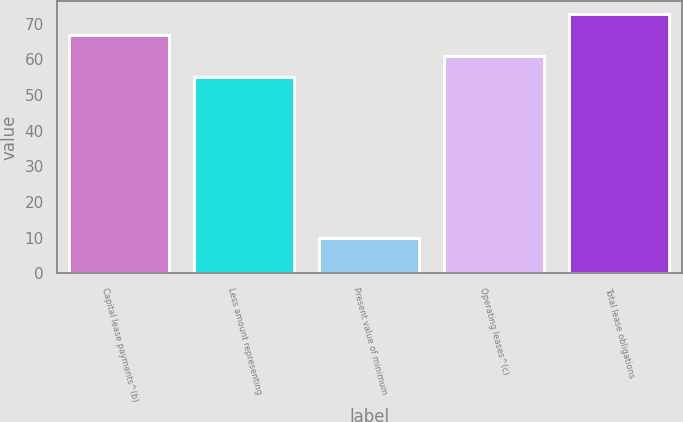<chart> <loc_0><loc_0><loc_500><loc_500><bar_chart><fcel>Capital lease payments^(b)<fcel>Less amount representing<fcel>Present value of minimum<fcel>Operating leases^(c)<fcel>Total lease obligations<nl><fcel>66.8<fcel>55<fcel>10<fcel>60.9<fcel>72.7<nl></chart> 